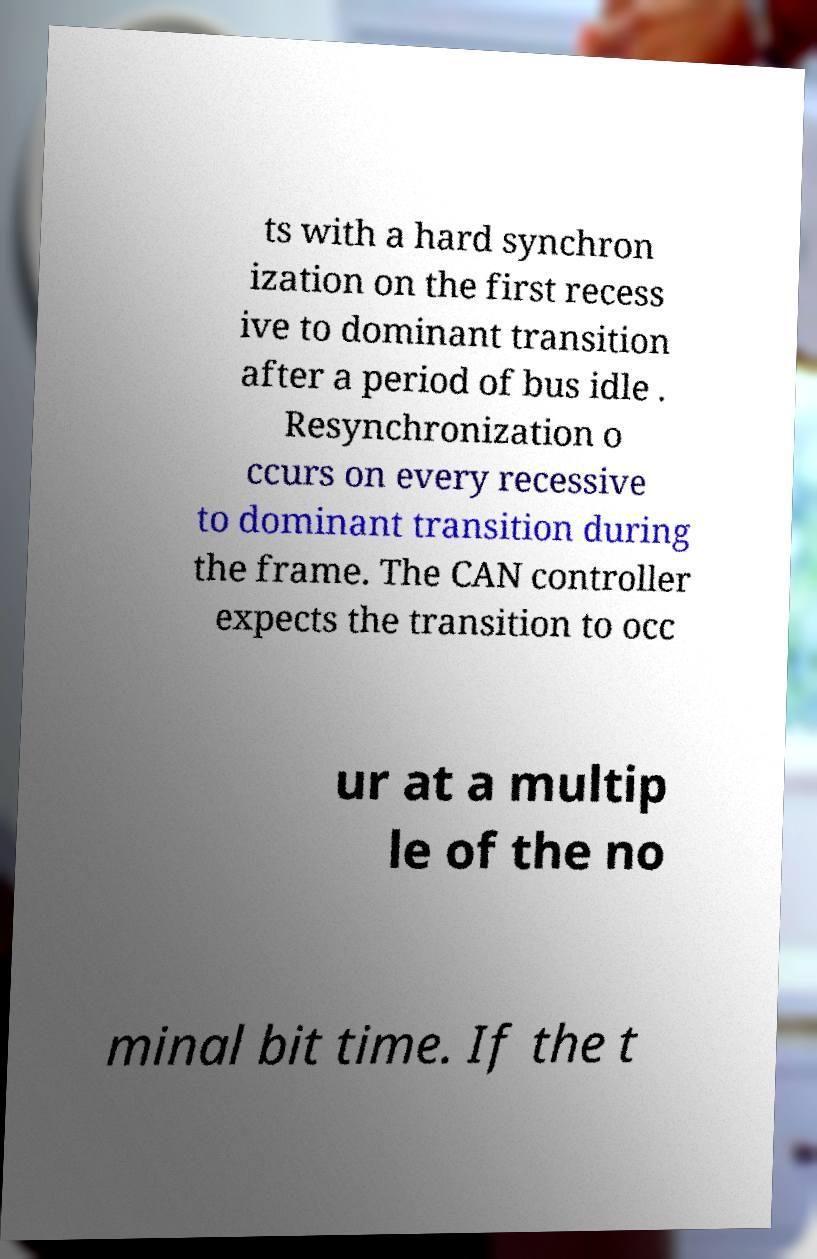Please identify and transcribe the text found in this image. ts with a hard synchron ization on the first recess ive to dominant transition after a period of bus idle . Resynchronization o ccurs on every recessive to dominant transition during the frame. The CAN controller expects the transition to occ ur at a multip le of the no minal bit time. If the t 